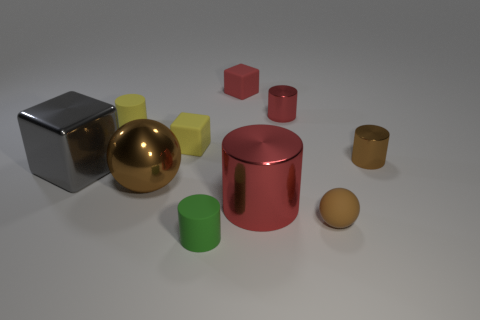What material is the tiny cylinder that is the same color as the large metallic cylinder?
Your answer should be very brief. Metal. There is a small brown object that is behind the small brown matte object; is it the same shape as the large red object?
Your answer should be compact. Yes. There is a small yellow object that is the same shape as the small red metallic object; what is it made of?
Offer a terse response. Rubber. What number of objects are large things on the right side of the small green rubber thing or small objects that are on the left side of the tiny brown metal cylinder?
Provide a short and direct response. 7. Do the large cylinder and the tiny cylinder that is in front of the tiny brown metallic thing have the same color?
Make the answer very short. No. There is a big red object that is made of the same material as the large gray cube; what shape is it?
Offer a very short reply. Cylinder. How many small yellow cylinders are there?
Offer a terse response. 1. What number of things are cubes to the right of the big brown shiny thing or small brown things?
Provide a short and direct response. 4. There is a small cylinder that is in front of the brown metal ball; is its color the same as the matte ball?
Provide a succinct answer. No. What number of other things are the same color as the large metal ball?
Make the answer very short. 2. 